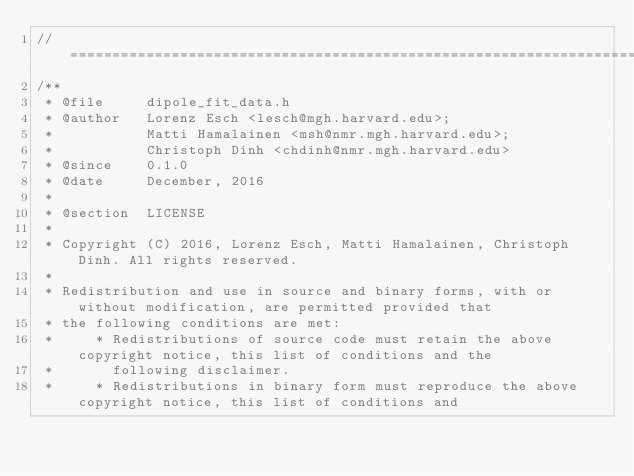<code> <loc_0><loc_0><loc_500><loc_500><_C_>//=============================================================================================================
/**
 * @file     dipole_fit_data.h
 * @author   Lorenz Esch <lesch@mgh.harvard.edu>;
 *           Matti Hamalainen <msh@nmr.mgh.harvard.edu>;
 *           Christoph Dinh <chdinh@nmr.mgh.harvard.edu>
 * @since    0.1.0
 * @date     December, 2016
 *
 * @section  LICENSE
 *
 * Copyright (C) 2016, Lorenz Esch, Matti Hamalainen, Christoph Dinh. All rights reserved.
 *
 * Redistribution and use in source and binary forms, with or without modification, are permitted provided that
 * the following conditions are met:
 *     * Redistributions of source code must retain the above copyright notice, this list of conditions and the
 *       following disclaimer.
 *     * Redistributions in binary form must reproduce the above copyright notice, this list of conditions and</code> 